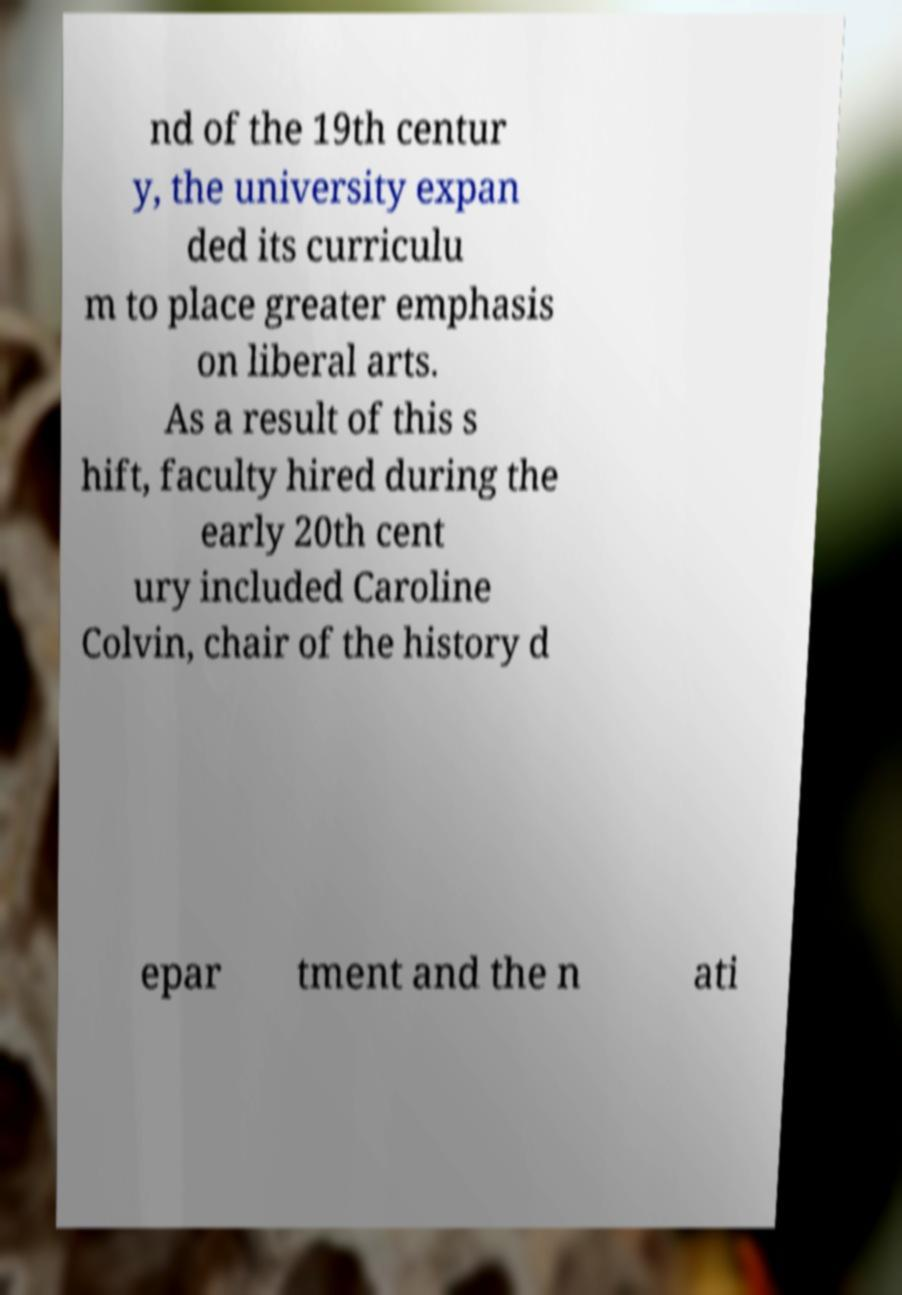Please identify and transcribe the text found in this image. nd of the 19th centur y, the university expan ded its curriculu m to place greater emphasis on liberal arts. As a result of this s hift, faculty hired during the early 20th cent ury included Caroline Colvin, chair of the history d epar tment and the n ati 